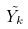<formula> <loc_0><loc_0><loc_500><loc_500>\tilde { Y _ { k } }</formula> 